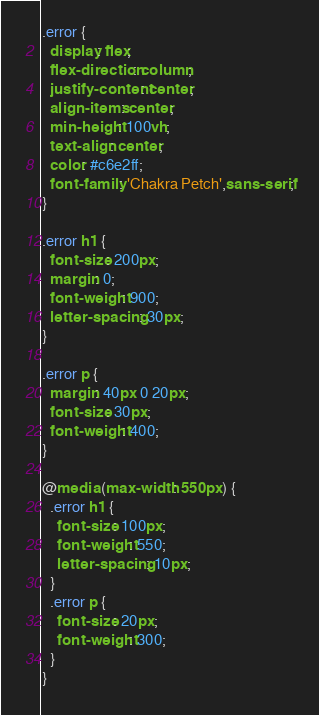<code> <loc_0><loc_0><loc_500><loc_500><_CSS_>.error {
  display: flex;
  flex-direction: column;
  justify-content: center;
  align-items: center;
  min-height: 100vh;
  text-align: center;
  color: #c6e2ff;
  font-family: 'Chakra Petch',sans-serif;
}

.error h1 {
  font-size: 200px;
  margin: 0;
  font-weight: 900;
  letter-spacing: 30px;
}

.error p {
  margin: 40px 0 20px;
  font-size: 30px;
  font-weight: 400;
}

@media (max-width: 550px) {
  .error h1 {
    font-size: 100px;
    font-weight: 550;
    letter-spacing: 10px;
  }
  .error p {
    font-size: 20px;
    font-weight: 300;
  }
}
</code> 